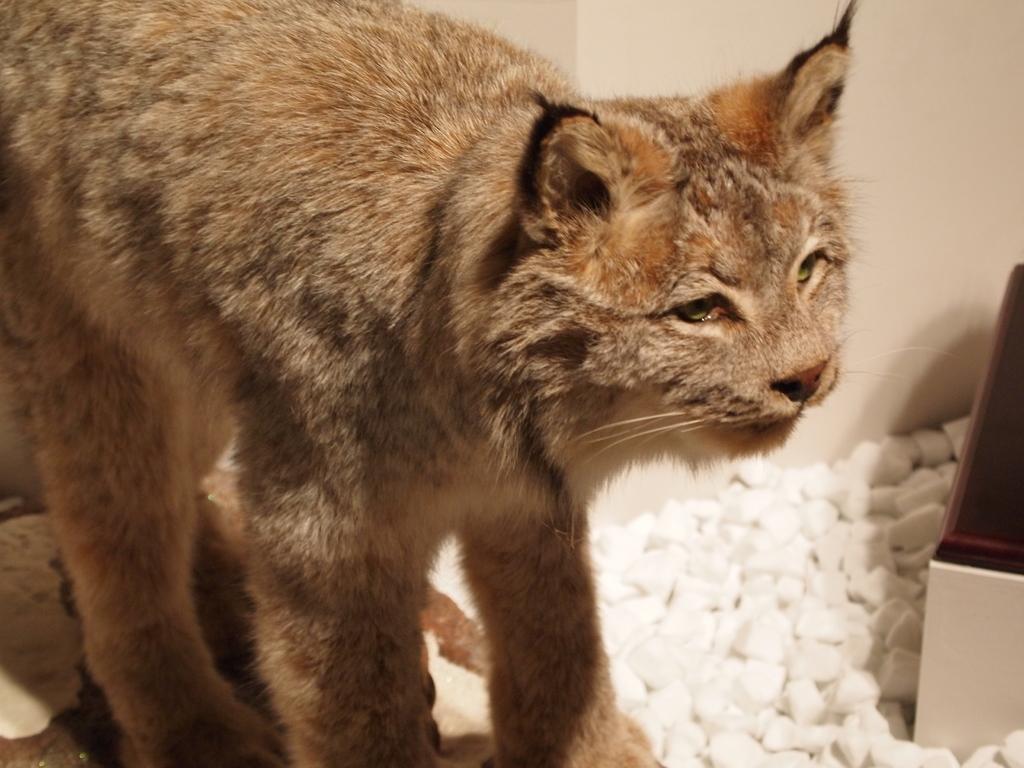Describe this image in one or two sentences. In this image we can a cat. There are many stones at the right side of the image. There is an object at the right side of the image. 